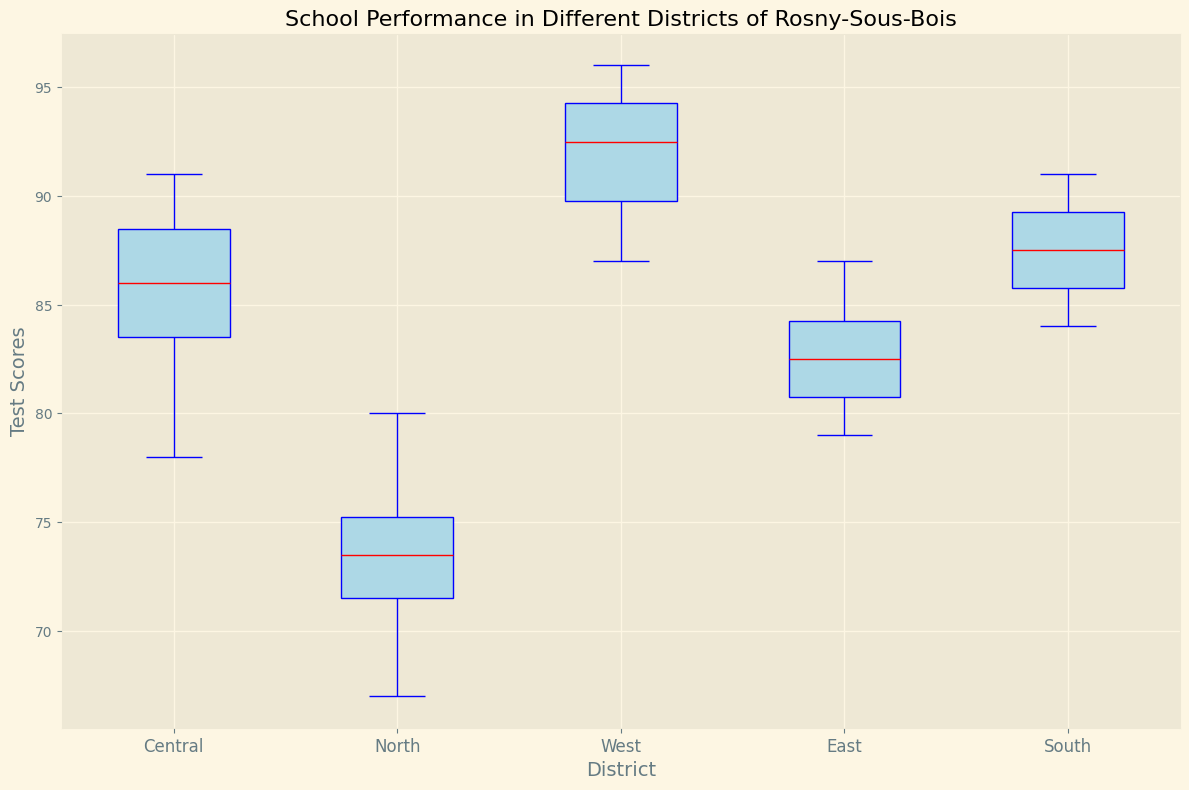What is the median test score in the Central district? Look for the red line inside the Central district's box in the plot, which represents the median.
Answer: 86.5 Which district has the highest median test score? Compare the red lines inside each district's box and identify the one that is highest on the axis.
Answer: West What is the range of test scores in the North district? Identify the top and bottom whiskers (highest and lowest points) for the North district and subtract the minimum from the maximum.
Answer: 67 to 80 How do the interquartile ranges (IQRs) of the East and Central districts compare? Compare the heights of the boxes (area between the lower and upper quartiles) for both East and Central districts.
Answer: East's IQR is slightly larger than Central's Which district has the widest spread in test scores? Look for the district with the longest distance between its whiskers.
Answer: West How do the upper quartiles of the North and South districts compare? Identify the top edges of the boxes for North and South districts and compare their positions.
Answer: South is higher than North Among all districts, which one has the smallest interquartile range (IQR)? Compare the sizes of the boxes (IQRs) across all districts and identify the smallest one.
Answer: South What is the interquartile range (IQR) for the West district? Find the distance between the top and bottom edges of the box for the West district.
Answer: 90 to 94.5 How does the median test score of the East district compare to its lower quartile? Identify the red line (median) and the bottom edge of the box (lower quartile) for the East district and compare their values.
Answer: The median is higher than the lower quartile Which district shows the greatest variability in test scores? Identify both the longest whiskers and the tallest boxes, which indicate larger variability.
Answer: West 